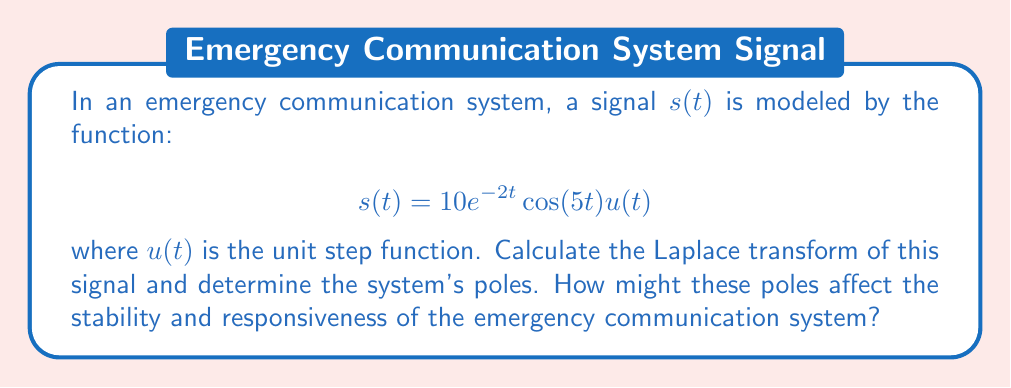Can you answer this question? Let's approach this problem step-by-step:

1) The Laplace transform of $s(t)$ is given by:

   $$S(s) = \mathcal{L}\{s(t)\} = \int_0^\infty 10e^{-2t}\cos(5t)e^{-st}dt$$

2) We can use the Laplace transform of a damped cosine function:

   $$\mathcal{L}\{e^{at}\cos(bt)\} = \frac{s-a}{(s-a)^2+b^2}$$

3) In our case, $a=-2$ and $b=5$. Also, we have a factor of 10. So:

   $$S(s) = \frac{10(s+2)}{(s+2)^2+5^2} = \frac{10(s+2)}{s^2+4s+29}$$

4) To find the poles, we need to find the roots of the denominator:

   $$s^2+4s+29 = 0$$

5) Using the quadratic formula:

   $$s = \frac{-4 \pm \sqrt{4^2-4(1)(29)}}{2(1)} = \frac{-4 \pm \sqrt{-100}}{2} = -2 \pm 5i$$

6) Therefore, the poles are at $s_1 = -2 + 5i$ and $s_2 = -2 - 5i$

7) The real part of the poles (-2) determines the decay rate of the signal. A negative real part indicates a stable system.

8) The imaginary part (±5i) determines the oscillation frequency of the system.

In the context of emergency communications, these poles suggest:

- Stability: The negative real part (-2) indicates that the system is stable and any disturbances will eventually die out.
- Responsiveness: The relatively small magnitude of the real part (-2) suggests a moderately fast response time.
- Oscillation: The imaginary part (±5i) indicates that the system will have some oscillatory behavior, which could affect signal clarity.
Answer: The Laplace transform of the signal is:

$$S(s) = \frac{10(s+2)}{s^2+4s+29}$$

The poles are $s_1 = -2 + 5i$ and $s_2 = -2 - 5i$

These poles indicate a stable system with moderately fast response time and some oscillatory behavior, which are generally favorable characteristics for an emergency communication system, balancing reliability with quick information transmission. 